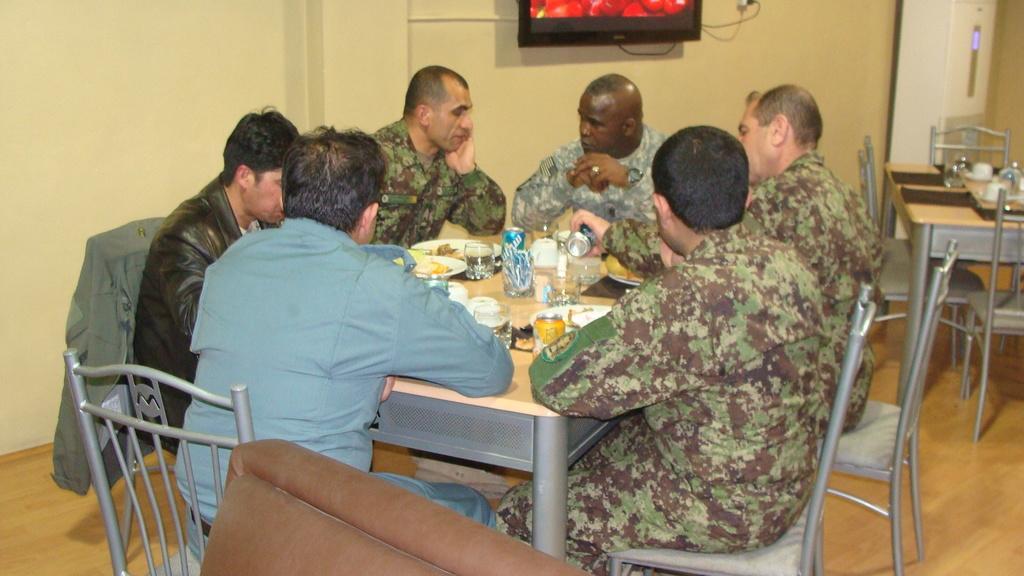Can you describe this image briefly? In the center of the picture there are people sitting in chairs, around a table. On the table there are plates, glasses, cups and other food items. On the right there are chairs and table, on the table there are cups and glasses. In the center of the background there is a television. At the bottom there is a couch. 